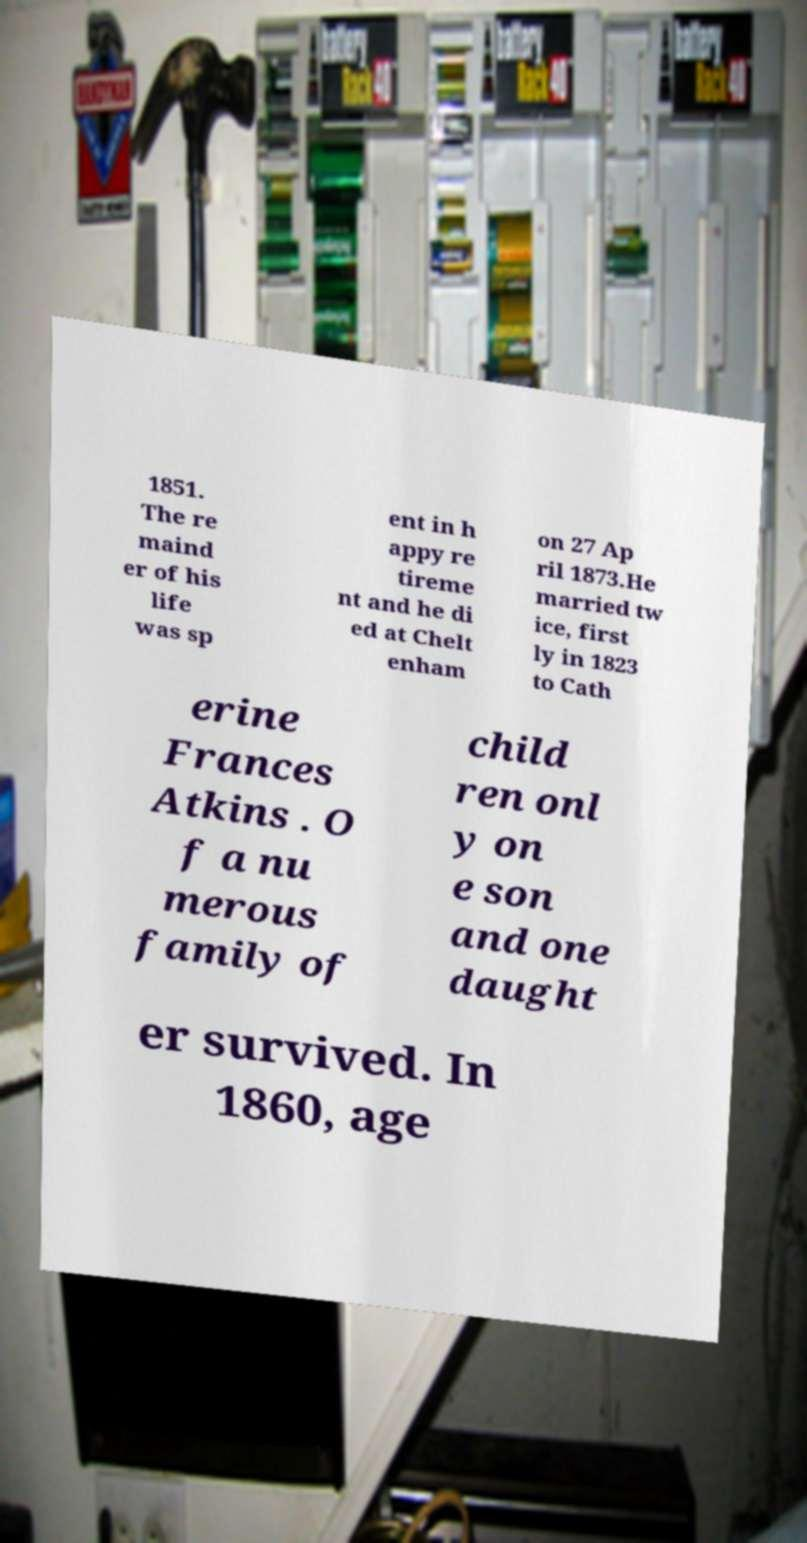I need the written content from this picture converted into text. Can you do that? 1851. The re maind er of his life was sp ent in h appy re tireme nt and he di ed at Chelt enham on 27 Ap ril 1873.He married tw ice, first ly in 1823 to Cath erine Frances Atkins . O f a nu merous family of child ren onl y on e son and one daught er survived. In 1860, age 